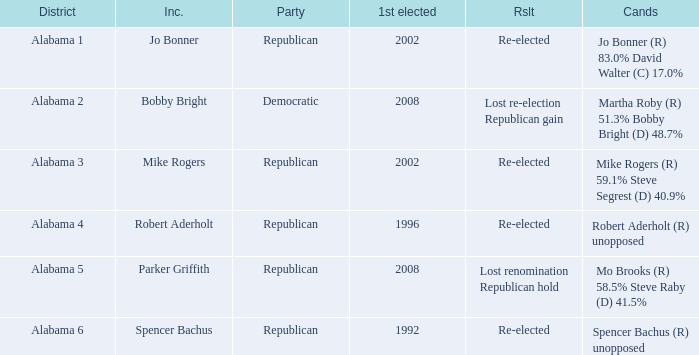Name the incumbent for lost renomination republican hold Parker Griffith. 